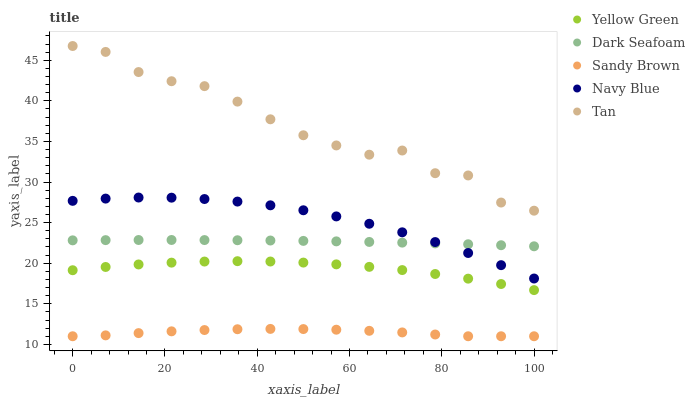Does Sandy Brown have the minimum area under the curve?
Answer yes or no. Yes. Does Tan have the maximum area under the curve?
Answer yes or no. Yes. Does Navy Blue have the minimum area under the curve?
Answer yes or no. No. Does Navy Blue have the maximum area under the curve?
Answer yes or no. No. Is Dark Seafoam the smoothest?
Answer yes or no. Yes. Is Tan the roughest?
Answer yes or no. Yes. Is Navy Blue the smoothest?
Answer yes or no. No. Is Navy Blue the roughest?
Answer yes or no. No. Does Sandy Brown have the lowest value?
Answer yes or no. Yes. Does Navy Blue have the lowest value?
Answer yes or no. No. Does Tan have the highest value?
Answer yes or no. Yes. Does Navy Blue have the highest value?
Answer yes or no. No. Is Yellow Green less than Tan?
Answer yes or no. Yes. Is Navy Blue greater than Sandy Brown?
Answer yes or no. Yes. Does Navy Blue intersect Dark Seafoam?
Answer yes or no. Yes. Is Navy Blue less than Dark Seafoam?
Answer yes or no. No. Is Navy Blue greater than Dark Seafoam?
Answer yes or no. No. Does Yellow Green intersect Tan?
Answer yes or no. No. 